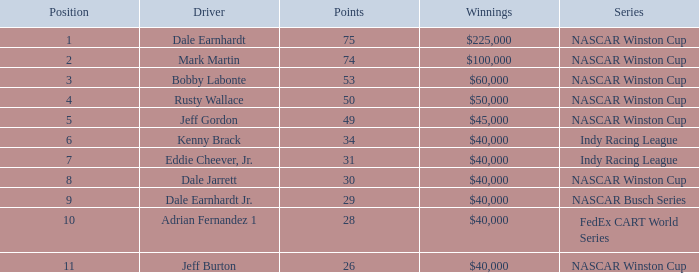In what position was the driver who won $60,000? 3.0. 